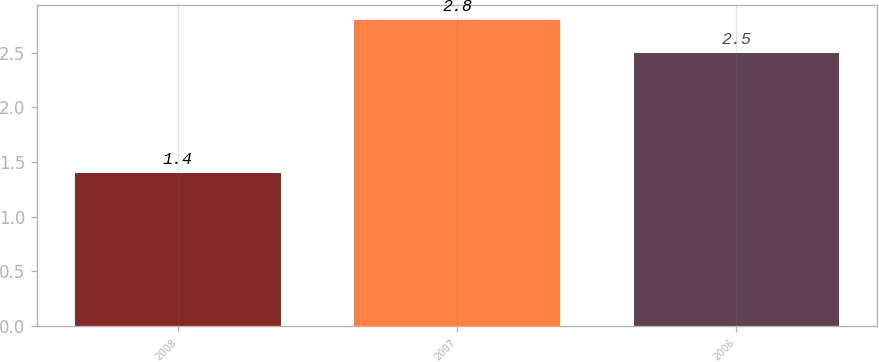Convert chart to OTSL. <chart><loc_0><loc_0><loc_500><loc_500><bar_chart><fcel>2008<fcel>2007<fcel>2006<nl><fcel>1.4<fcel>2.8<fcel>2.5<nl></chart> 